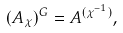<formula> <loc_0><loc_0><loc_500><loc_500>( A _ { \chi } ) ^ { G } = A ^ { ( \chi ^ { - 1 } ) } ,</formula> 